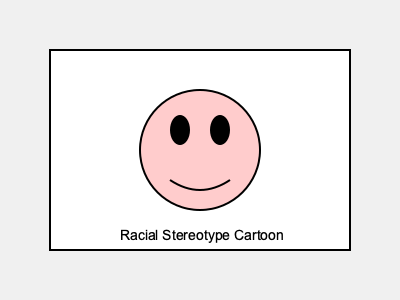As a newspaper editor, how would you assess the effectiveness of this cartoon in addressing racial issues, considering the use of stereotypical features? To assess the effectiveness of this cartoon in addressing racial issues, consider the following steps:

1. Analyze the visual elements:
   - The cartoon depicts a face with exaggerated features often associated with racial stereotypes.
   - Large, round eyes and a prominent mouth are common stereotypical depictions.

2. Consider the intent:
   - Political cartoons often use exaggeration to make a point or provoke thought.
   - The cartoonist may be attempting to highlight the issue of racial stereotyping.

3. Evaluate the potential impact:
   - Such depictions can be provocative and spark discussion about racial issues.
   - However, they may also reinforce harmful stereotypes if not contextualized properly.

4. Assess the balance:
   - Effective political cartoons should challenge viewers without crossing ethical boundaries.
   - The cartoon should prompt reflection on racial issues rather than simply perpetuate stereotypes.

5. Consider the audience:
   - The newspaper's readership and their potential reactions to such imagery are important factors.
   - The cartoon's effectiveness may vary depending on the cultural context and sensitivity of the audience.

6. Examine the accompanying text or context:
   - The cartoon's placement within the newspaper and any accompanying article or caption would influence its interpretation.

7. Reflect on journalistic responsibility:
   - As an editor, consider whether the cartoon contributes meaningfully to the discourse on racial issues.
   - Evaluate if it aligns with the newspaper's editorial standards and ethical guidelines.

An effective assessment would weigh the cartoon's potential to stimulate important conversations against the risk of reinforcing harmful stereotypes.
Answer: Provocative but risks reinforcing stereotypes; effectiveness depends on context and audience. 